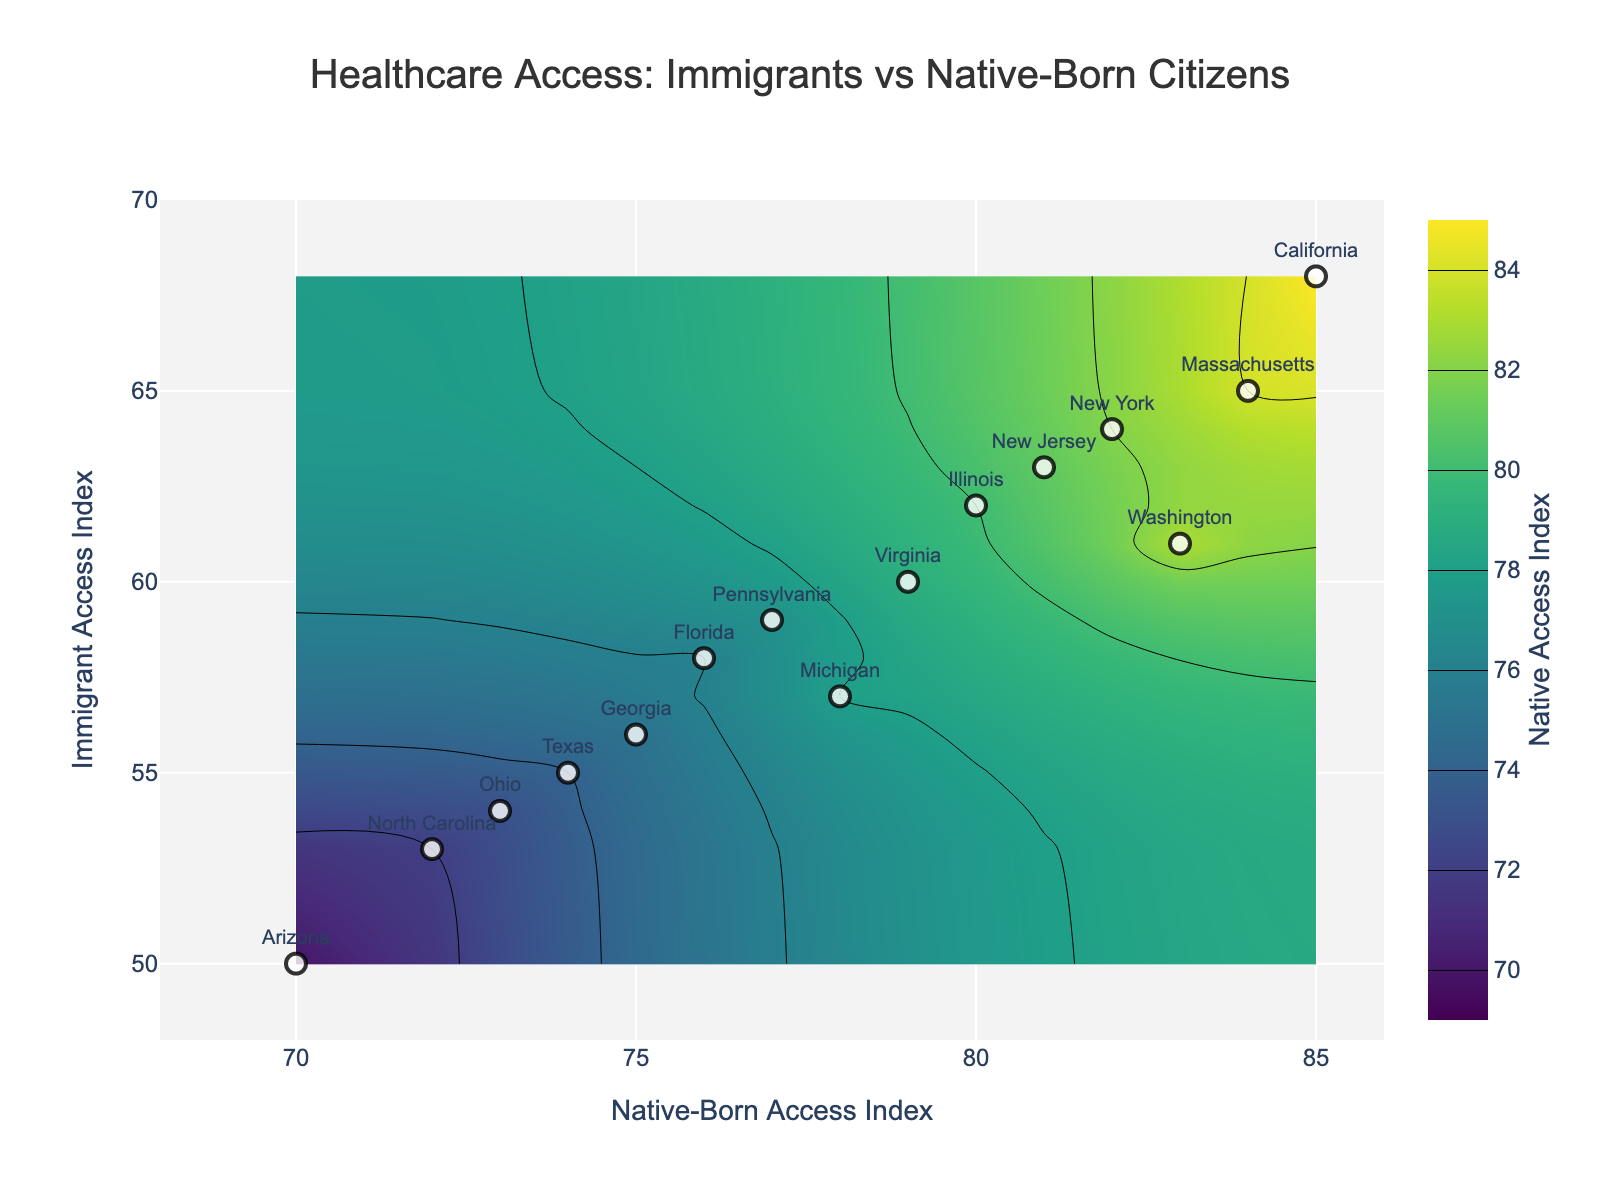What is the title of the figure? The title is displayed at the top center of the figure.
Answer: Healthcare Access: Immigrants vs Native-Born Citizens How is the native-born access index distributed in different states? By looking at the contour plot, the native-born access index values are concentrated between 70 and 85, as indicated by the color gradient and labels.
Answer: Between 70 and 85 Which state has the lowest immigrant access index? By checking the Y-axis value (Immigrant Access Index) and the labels for each data point, we can find the lowest value. Arizona has the lowest immigrant access index of 50.
Answer: Arizona Which state has a higher native-born access index than immigrant access index by more than 20 points? By comparing the difference between the native-born and immigrant access indices for each state, we can see that California (85 - 68 = 17) and Massachusetts (84 - 65 = 19) do not meet the criterion, but no state exceeds a difference of 20 points.
Answer: None What is the range of the immigrant access index displayed in the figure? The range for immigrant access index can be identified from the Y-axis, which spans from 48 to 70.
Answer: 48 to 70 Which two states have the most similar access indices for both immigrants and native-born citizens? By comparing the proximity of the data points to the diagonal line of equality (y=x) and checking the state labels, Washington (61, 83) and Illinois (62, 80) are close but not the closest. Virginia (60, 79) and Pennsylvania (59, 77) are very similar to each other.
Answer: Virginia and Pennsylvania How many states have an immigrant access index above 60? By counting the number of points above the y-value of 60 and checking the state labels, we find 5 states: California, New York, Illinois, New Jersey, Massachusetts.
Answer: 5 states Which state has the largest gap between immigrant and native-born access indices? By calculating the difference for each state and identifying the largest gap, Arizona has the largest gap with a 20 point difference (70 - 50).
Answer: Arizona What is the average native-born access index for states shown in the figure? Adding the native-born access indices and dividing by 15 (the number of states), we get: (85 + 74 + 82 + 76 + 80 + 77 + 73 + 75 + 72 + 78 + 81 + 79 + 83 + 70 + 84) / 15 = 1209 / 15 = 80.6
Answer: 80.6 